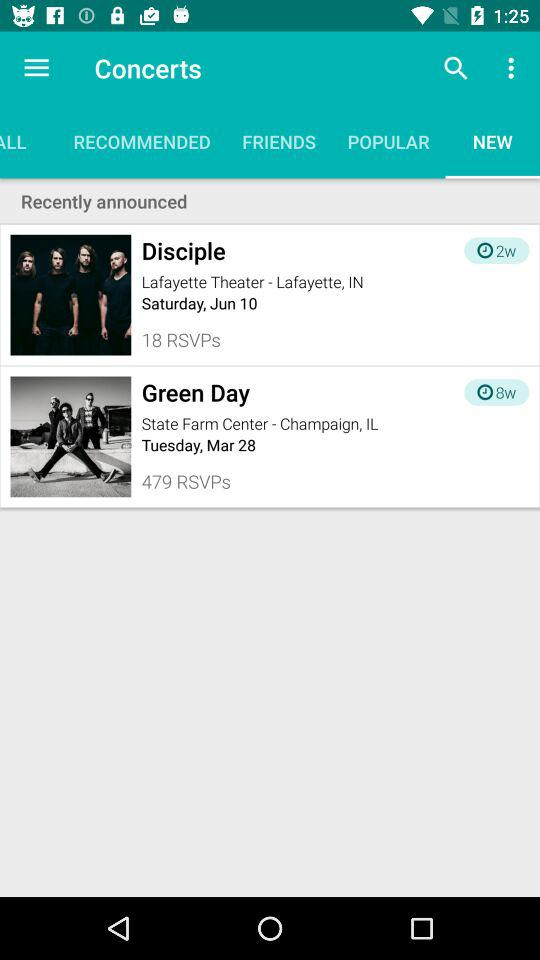How many more RSVPs does the Green Day concert have than the Disciple concert?
Answer the question using a single word or phrase. 461 